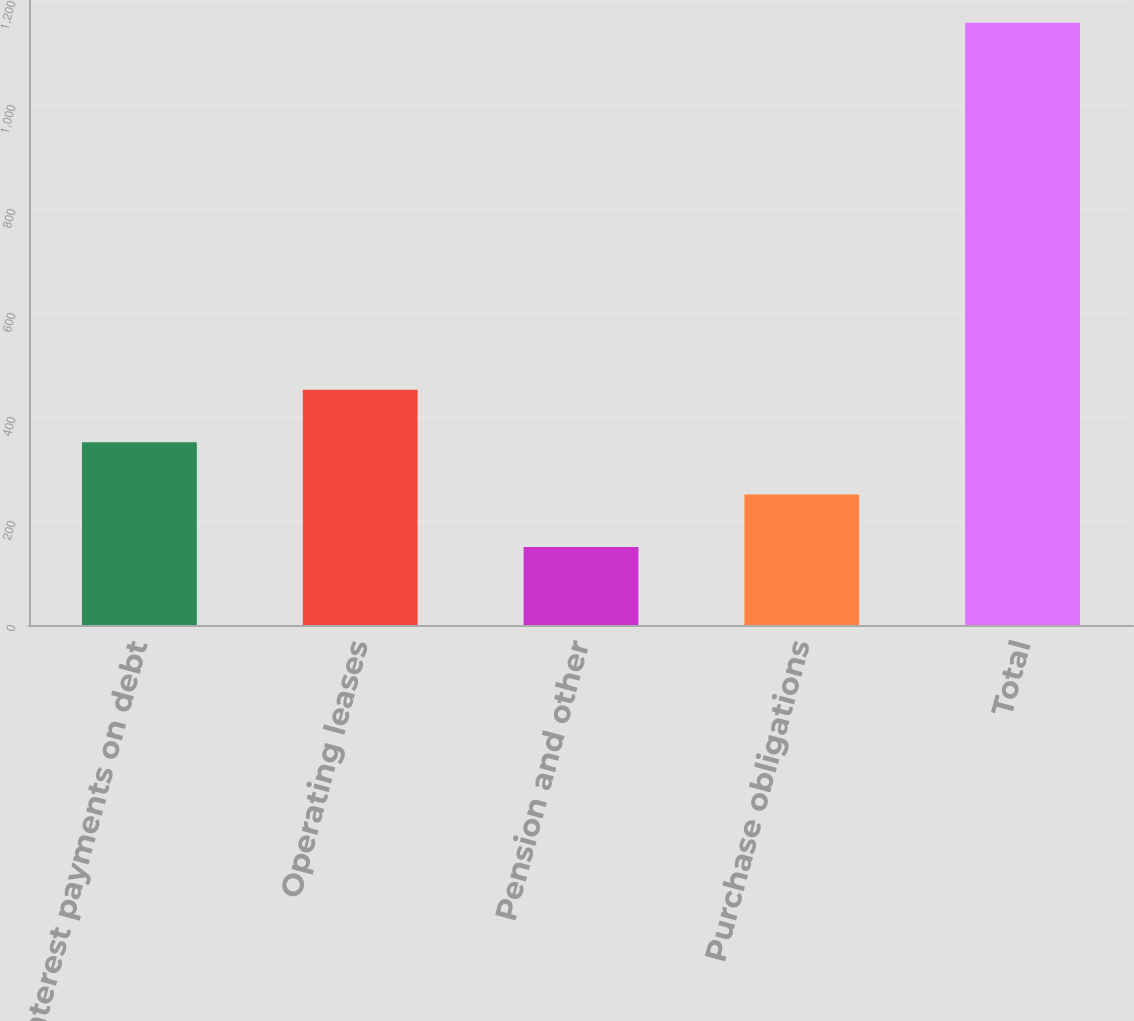Convert chart. <chart><loc_0><loc_0><loc_500><loc_500><bar_chart><fcel>Interest payments on debt<fcel>Operating leases<fcel>Pension and other<fcel>Purchase obligations<fcel>Total<nl><fcel>351.6<fcel>452.4<fcel>150<fcel>250.8<fcel>1158<nl></chart> 